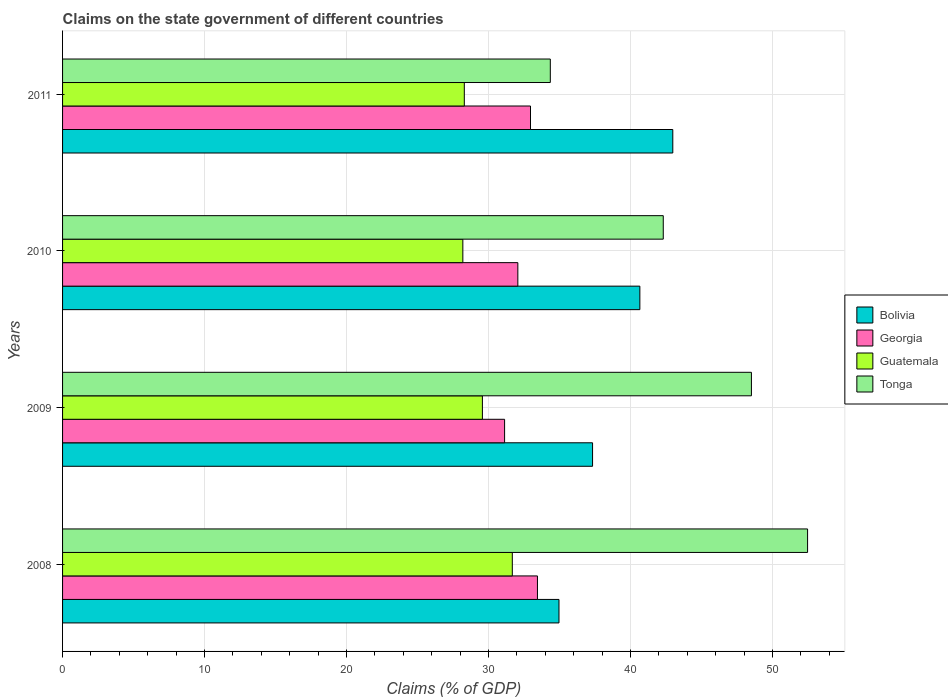How many groups of bars are there?
Your response must be concise. 4. Are the number of bars on each tick of the Y-axis equal?
Provide a succinct answer. Yes. How many bars are there on the 1st tick from the top?
Provide a succinct answer. 4. What is the percentage of GDP claimed on the state government in Tonga in 2011?
Provide a succinct answer. 34.35. Across all years, what is the maximum percentage of GDP claimed on the state government in Bolivia?
Make the answer very short. 42.97. Across all years, what is the minimum percentage of GDP claimed on the state government in Bolivia?
Provide a short and direct response. 34.96. In which year was the percentage of GDP claimed on the state government in Guatemala minimum?
Offer a very short reply. 2010. What is the total percentage of GDP claimed on the state government in Georgia in the graph?
Keep it short and to the point. 129.59. What is the difference between the percentage of GDP claimed on the state government in Georgia in 2009 and that in 2010?
Your answer should be compact. -0.93. What is the difference between the percentage of GDP claimed on the state government in Bolivia in 2009 and the percentage of GDP claimed on the state government in Tonga in 2011?
Offer a very short reply. 2.98. What is the average percentage of GDP claimed on the state government in Bolivia per year?
Offer a terse response. 38.98. In the year 2010, what is the difference between the percentage of GDP claimed on the state government in Bolivia and percentage of GDP claimed on the state government in Georgia?
Your answer should be compact. 8.59. In how many years, is the percentage of GDP claimed on the state government in Guatemala greater than 10 %?
Offer a terse response. 4. What is the ratio of the percentage of GDP claimed on the state government in Guatemala in 2008 to that in 2009?
Your answer should be very brief. 1.07. Is the percentage of GDP claimed on the state government in Georgia in 2009 less than that in 2011?
Give a very brief answer. Yes. What is the difference between the highest and the second highest percentage of GDP claimed on the state government in Tonga?
Your answer should be very brief. 3.96. What is the difference between the highest and the lowest percentage of GDP claimed on the state government in Georgia?
Give a very brief answer. 2.31. In how many years, is the percentage of GDP claimed on the state government in Guatemala greater than the average percentage of GDP claimed on the state government in Guatemala taken over all years?
Provide a short and direct response. 2. Is it the case that in every year, the sum of the percentage of GDP claimed on the state government in Guatemala and percentage of GDP claimed on the state government in Tonga is greater than the sum of percentage of GDP claimed on the state government in Georgia and percentage of GDP claimed on the state government in Bolivia?
Keep it short and to the point. No. What does the 2nd bar from the top in 2011 represents?
Offer a very short reply. Guatemala. What does the 2nd bar from the bottom in 2010 represents?
Provide a succinct answer. Georgia. How many bars are there?
Offer a terse response. 16. Are all the bars in the graph horizontal?
Give a very brief answer. Yes. How many years are there in the graph?
Ensure brevity in your answer.  4. Are the values on the major ticks of X-axis written in scientific E-notation?
Your answer should be very brief. No. Does the graph contain any zero values?
Provide a succinct answer. No. Does the graph contain grids?
Offer a terse response. Yes. Where does the legend appear in the graph?
Give a very brief answer. Center right. How are the legend labels stacked?
Ensure brevity in your answer.  Vertical. What is the title of the graph?
Give a very brief answer. Claims on the state government of different countries. Does "Low income" appear as one of the legend labels in the graph?
Ensure brevity in your answer.  No. What is the label or title of the X-axis?
Give a very brief answer. Claims (% of GDP). What is the Claims (% of GDP) of Bolivia in 2008?
Give a very brief answer. 34.96. What is the Claims (% of GDP) of Georgia in 2008?
Offer a very short reply. 33.44. What is the Claims (% of GDP) in Guatemala in 2008?
Provide a succinct answer. 31.67. What is the Claims (% of GDP) in Tonga in 2008?
Offer a terse response. 52.47. What is the Claims (% of GDP) in Bolivia in 2009?
Ensure brevity in your answer.  37.32. What is the Claims (% of GDP) in Georgia in 2009?
Give a very brief answer. 31.13. What is the Claims (% of GDP) of Guatemala in 2009?
Your answer should be very brief. 29.57. What is the Claims (% of GDP) of Tonga in 2009?
Your response must be concise. 48.51. What is the Claims (% of GDP) in Bolivia in 2010?
Your answer should be very brief. 40.65. What is the Claims (% of GDP) of Georgia in 2010?
Your answer should be very brief. 32.06. What is the Claims (% of GDP) of Guatemala in 2010?
Offer a very short reply. 28.19. What is the Claims (% of GDP) in Tonga in 2010?
Provide a short and direct response. 42.3. What is the Claims (% of GDP) in Bolivia in 2011?
Give a very brief answer. 42.97. What is the Claims (% of GDP) in Georgia in 2011?
Your response must be concise. 32.95. What is the Claims (% of GDP) in Guatemala in 2011?
Keep it short and to the point. 28.29. What is the Claims (% of GDP) in Tonga in 2011?
Your answer should be compact. 34.35. Across all years, what is the maximum Claims (% of GDP) of Bolivia?
Give a very brief answer. 42.97. Across all years, what is the maximum Claims (% of GDP) of Georgia?
Ensure brevity in your answer.  33.44. Across all years, what is the maximum Claims (% of GDP) in Guatemala?
Make the answer very short. 31.67. Across all years, what is the maximum Claims (% of GDP) in Tonga?
Make the answer very short. 52.47. Across all years, what is the minimum Claims (% of GDP) in Bolivia?
Your response must be concise. 34.96. Across all years, what is the minimum Claims (% of GDP) in Georgia?
Keep it short and to the point. 31.13. Across all years, what is the minimum Claims (% of GDP) of Guatemala?
Offer a terse response. 28.19. Across all years, what is the minimum Claims (% of GDP) of Tonga?
Provide a short and direct response. 34.35. What is the total Claims (% of GDP) in Bolivia in the graph?
Your answer should be compact. 155.91. What is the total Claims (% of GDP) of Georgia in the graph?
Give a very brief answer. 129.59. What is the total Claims (% of GDP) in Guatemala in the graph?
Provide a succinct answer. 117.72. What is the total Claims (% of GDP) in Tonga in the graph?
Make the answer very short. 177.63. What is the difference between the Claims (% of GDP) in Bolivia in 2008 and that in 2009?
Your response must be concise. -2.36. What is the difference between the Claims (% of GDP) in Georgia in 2008 and that in 2009?
Make the answer very short. 2.31. What is the difference between the Claims (% of GDP) in Guatemala in 2008 and that in 2009?
Give a very brief answer. 2.11. What is the difference between the Claims (% of GDP) of Tonga in 2008 and that in 2009?
Your answer should be very brief. 3.96. What is the difference between the Claims (% of GDP) of Bolivia in 2008 and that in 2010?
Keep it short and to the point. -5.7. What is the difference between the Claims (% of GDP) of Georgia in 2008 and that in 2010?
Your answer should be very brief. 1.38. What is the difference between the Claims (% of GDP) of Guatemala in 2008 and that in 2010?
Keep it short and to the point. 3.48. What is the difference between the Claims (% of GDP) in Tonga in 2008 and that in 2010?
Your answer should be compact. 10.16. What is the difference between the Claims (% of GDP) of Bolivia in 2008 and that in 2011?
Ensure brevity in your answer.  -8.02. What is the difference between the Claims (% of GDP) in Georgia in 2008 and that in 2011?
Your answer should be compact. 0.49. What is the difference between the Claims (% of GDP) in Guatemala in 2008 and that in 2011?
Your response must be concise. 3.38. What is the difference between the Claims (% of GDP) of Tonga in 2008 and that in 2011?
Your response must be concise. 18.12. What is the difference between the Claims (% of GDP) of Bolivia in 2009 and that in 2010?
Give a very brief answer. -3.33. What is the difference between the Claims (% of GDP) in Georgia in 2009 and that in 2010?
Provide a succinct answer. -0.93. What is the difference between the Claims (% of GDP) in Guatemala in 2009 and that in 2010?
Your response must be concise. 1.38. What is the difference between the Claims (% of GDP) of Tonga in 2009 and that in 2010?
Offer a terse response. 6.21. What is the difference between the Claims (% of GDP) of Bolivia in 2009 and that in 2011?
Provide a succinct answer. -5.65. What is the difference between the Claims (% of GDP) of Georgia in 2009 and that in 2011?
Keep it short and to the point. -1.82. What is the difference between the Claims (% of GDP) in Guatemala in 2009 and that in 2011?
Keep it short and to the point. 1.27. What is the difference between the Claims (% of GDP) of Tonga in 2009 and that in 2011?
Provide a succinct answer. 14.16. What is the difference between the Claims (% of GDP) of Bolivia in 2010 and that in 2011?
Your answer should be compact. -2.32. What is the difference between the Claims (% of GDP) in Georgia in 2010 and that in 2011?
Your response must be concise. -0.89. What is the difference between the Claims (% of GDP) in Guatemala in 2010 and that in 2011?
Your answer should be very brief. -0.1. What is the difference between the Claims (% of GDP) in Tonga in 2010 and that in 2011?
Your answer should be very brief. 7.95. What is the difference between the Claims (% of GDP) of Bolivia in 2008 and the Claims (% of GDP) of Georgia in 2009?
Your answer should be compact. 3.83. What is the difference between the Claims (% of GDP) in Bolivia in 2008 and the Claims (% of GDP) in Guatemala in 2009?
Your answer should be compact. 5.39. What is the difference between the Claims (% of GDP) of Bolivia in 2008 and the Claims (% of GDP) of Tonga in 2009?
Your response must be concise. -13.55. What is the difference between the Claims (% of GDP) in Georgia in 2008 and the Claims (% of GDP) in Guatemala in 2009?
Offer a terse response. 3.88. What is the difference between the Claims (% of GDP) in Georgia in 2008 and the Claims (% of GDP) in Tonga in 2009?
Make the answer very short. -15.07. What is the difference between the Claims (% of GDP) in Guatemala in 2008 and the Claims (% of GDP) in Tonga in 2009?
Provide a succinct answer. -16.84. What is the difference between the Claims (% of GDP) in Bolivia in 2008 and the Claims (% of GDP) in Georgia in 2010?
Offer a terse response. 2.9. What is the difference between the Claims (% of GDP) of Bolivia in 2008 and the Claims (% of GDP) of Guatemala in 2010?
Your answer should be very brief. 6.77. What is the difference between the Claims (% of GDP) of Bolivia in 2008 and the Claims (% of GDP) of Tonga in 2010?
Your answer should be compact. -7.34. What is the difference between the Claims (% of GDP) of Georgia in 2008 and the Claims (% of GDP) of Guatemala in 2010?
Give a very brief answer. 5.25. What is the difference between the Claims (% of GDP) of Georgia in 2008 and the Claims (% of GDP) of Tonga in 2010?
Your response must be concise. -8.86. What is the difference between the Claims (% of GDP) in Guatemala in 2008 and the Claims (% of GDP) in Tonga in 2010?
Give a very brief answer. -10.63. What is the difference between the Claims (% of GDP) of Bolivia in 2008 and the Claims (% of GDP) of Georgia in 2011?
Provide a succinct answer. 2.01. What is the difference between the Claims (% of GDP) in Bolivia in 2008 and the Claims (% of GDP) in Guatemala in 2011?
Offer a terse response. 6.67. What is the difference between the Claims (% of GDP) in Bolivia in 2008 and the Claims (% of GDP) in Tonga in 2011?
Provide a short and direct response. 0.61. What is the difference between the Claims (% of GDP) of Georgia in 2008 and the Claims (% of GDP) of Guatemala in 2011?
Offer a terse response. 5.15. What is the difference between the Claims (% of GDP) in Georgia in 2008 and the Claims (% of GDP) in Tonga in 2011?
Your answer should be very brief. -0.91. What is the difference between the Claims (% of GDP) in Guatemala in 2008 and the Claims (% of GDP) in Tonga in 2011?
Your response must be concise. -2.68. What is the difference between the Claims (% of GDP) of Bolivia in 2009 and the Claims (% of GDP) of Georgia in 2010?
Offer a very short reply. 5.26. What is the difference between the Claims (% of GDP) in Bolivia in 2009 and the Claims (% of GDP) in Guatemala in 2010?
Provide a short and direct response. 9.14. What is the difference between the Claims (% of GDP) of Bolivia in 2009 and the Claims (% of GDP) of Tonga in 2010?
Your answer should be compact. -4.98. What is the difference between the Claims (% of GDP) in Georgia in 2009 and the Claims (% of GDP) in Guatemala in 2010?
Offer a very short reply. 2.94. What is the difference between the Claims (% of GDP) of Georgia in 2009 and the Claims (% of GDP) of Tonga in 2010?
Provide a succinct answer. -11.17. What is the difference between the Claims (% of GDP) of Guatemala in 2009 and the Claims (% of GDP) of Tonga in 2010?
Your response must be concise. -12.74. What is the difference between the Claims (% of GDP) in Bolivia in 2009 and the Claims (% of GDP) in Georgia in 2011?
Offer a terse response. 4.37. What is the difference between the Claims (% of GDP) in Bolivia in 2009 and the Claims (% of GDP) in Guatemala in 2011?
Offer a terse response. 9.03. What is the difference between the Claims (% of GDP) in Bolivia in 2009 and the Claims (% of GDP) in Tonga in 2011?
Your response must be concise. 2.98. What is the difference between the Claims (% of GDP) of Georgia in 2009 and the Claims (% of GDP) of Guatemala in 2011?
Provide a short and direct response. 2.84. What is the difference between the Claims (% of GDP) in Georgia in 2009 and the Claims (% of GDP) in Tonga in 2011?
Offer a terse response. -3.22. What is the difference between the Claims (% of GDP) of Guatemala in 2009 and the Claims (% of GDP) of Tonga in 2011?
Give a very brief answer. -4.78. What is the difference between the Claims (% of GDP) in Bolivia in 2010 and the Claims (% of GDP) in Georgia in 2011?
Give a very brief answer. 7.7. What is the difference between the Claims (% of GDP) of Bolivia in 2010 and the Claims (% of GDP) of Guatemala in 2011?
Provide a short and direct response. 12.36. What is the difference between the Claims (% of GDP) of Bolivia in 2010 and the Claims (% of GDP) of Tonga in 2011?
Make the answer very short. 6.31. What is the difference between the Claims (% of GDP) in Georgia in 2010 and the Claims (% of GDP) in Guatemala in 2011?
Ensure brevity in your answer.  3.77. What is the difference between the Claims (% of GDP) of Georgia in 2010 and the Claims (% of GDP) of Tonga in 2011?
Provide a short and direct response. -2.29. What is the difference between the Claims (% of GDP) in Guatemala in 2010 and the Claims (% of GDP) in Tonga in 2011?
Make the answer very short. -6.16. What is the average Claims (% of GDP) in Bolivia per year?
Keep it short and to the point. 38.98. What is the average Claims (% of GDP) in Georgia per year?
Your response must be concise. 32.4. What is the average Claims (% of GDP) in Guatemala per year?
Ensure brevity in your answer.  29.43. What is the average Claims (% of GDP) in Tonga per year?
Your answer should be compact. 44.41. In the year 2008, what is the difference between the Claims (% of GDP) of Bolivia and Claims (% of GDP) of Georgia?
Give a very brief answer. 1.52. In the year 2008, what is the difference between the Claims (% of GDP) of Bolivia and Claims (% of GDP) of Guatemala?
Offer a very short reply. 3.29. In the year 2008, what is the difference between the Claims (% of GDP) of Bolivia and Claims (% of GDP) of Tonga?
Your response must be concise. -17.51. In the year 2008, what is the difference between the Claims (% of GDP) in Georgia and Claims (% of GDP) in Guatemala?
Provide a short and direct response. 1.77. In the year 2008, what is the difference between the Claims (% of GDP) in Georgia and Claims (% of GDP) in Tonga?
Ensure brevity in your answer.  -19.02. In the year 2008, what is the difference between the Claims (% of GDP) in Guatemala and Claims (% of GDP) in Tonga?
Give a very brief answer. -20.79. In the year 2009, what is the difference between the Claims (% of GDP) of Bolivia and Claims (% of GDP) of Georgia?
Offer a terse response. 6.2. In the year 2009, what is the difference between the Claims (% of GDP) of Bolivia and Claims (% of GDP) of Guatemala?
Keep it short and to the point. 7.76. In the year 2009, what is the difference between the Claims (% of GDP) of Bolivia and Claims (% of GDP) of Tonga?
Provide a succinct answer. -11.19. In the year 2009, what is the difference between the Claims (% of GDP) in Georgia and Claims (% of GDP) in Guatemala?
Offer a terse response. 1.56. In the year 2009, what is the difference between the Claims (% of GDP) in Georgia and Claims (% of GDP) in Tonga?
Keep it short and to the point. -17.38. In the year 2009, what is the difference between the Claims (% of GDP) in Guatemala and Claims (% of GDP) in Tonga?
Offer a terse response. -18.94. In the year 2010, what is the difference between the Claims (% of GDP) in Bolivia and Claims (% of GDP) in Georgia?
Provide a short and direct response. 8.59. In the year 2010, what is the difference between the Claims (% of GDP) of Bolivia and Claims (% of GDP) of Guatemala?
Offer a terse response. 12.47. In the year 2010, what is the difference between the Claims (% of GDP) in Bolivia and Claims (% of GDP) in Tonga?
Keep it short and to the point. -1.65. In the year 2010, what is the difference between the Claims (% of GDP) in Georgia and Claims (% of GDP) in Guatemala?
Ensure brevity in your answer.  3.87. In the year 2010, what is the difference between the Claims (% of GDP) in Georgia and Claims (% of GDP) in Tonga?
Offer a terse response. -10.24. In the year 2010, what is the difference between the Claims (% of GDP) in Guatemala and Claims (% of GDP) in Tonga?
Give a very brief answer. -14.11. In the year 2011, what is the difference between the Claims (% of GDP) in Bolivia and Claims (% of GDP) in Georgia?
Keep it short and to the point. 10.02. In the year 2011, what is the difference between the Claims (% of GDP) in Bolivia and Claims (% of GDP) in Guatemala?
Ensure brevity in your answer.  14.68. In the year 2011, what is the difference between the Claims (% of GDP) in Bolivia and Claims (% of GDP) in Tonga?
Your answer should be compact. 8.63. In the year 2011, what is the difference between the Claims (% of GDP) of Georgia and Claims (% of GDP) of Guatemala?
Offer a terse response. 4.66. In the year 2011, what is the difference between the Claims (% of GDP) of Georgia and Claims (% of GDP) of Tonga?
Keep it short and to the point. -1.4. In the year 2011, what is the difference between the Claims (% of GDP) of Guatemala and Claims (% of GDP) of Tonga?
Offer a terse response. -6.06. What is the ratio of the Claims (% of GDP) in Bolivia in 2008 to that in 2009?
Offer a terse response. 0.94. What is the ratio of the Claims (% of GDP) in Georgia in 2008 to that in 2009?
Provide a short and direct response. 1.07. What is the ratio of the Claims (% of GDP) of Guatemala in 2008 to that in 2009?
Keep it short and to the point. 1.07. What is the ratio of the Claims (% of GDP) of Tonga in 2008 to that in 2009?
Your answer should be compact. 1.08. What is the ratio of the Claims (% of GDP) in Bolivia in 2008 to that in 2010?
Provide a short and direct response. 0.86. What is the ratio of the Claims (% of GDP) in Georgia in 2008 to that in 2010?
Offer a very short reply. 1.04. What is the ratio of the Claims (% of GDP) in Guatemala in 2008 to that in 2010?
Provide a succinct answer. 1.12. What is the ratio of the Claims (% of GDP) in Tonga in 2008 to that in 2010?
Make the answer very short. 1.24. What is the ratio of the Claims (% of GDP) of Bolivia in 2008 to that in 2011?
Provide a succinct answer. 0.81. What is the ratio of the Claims (% of GDP) in Georgia in 2008 to that in 2011?
Offer a terse response. 1.01. What is the ratio of the Claims (% of GDP) of Guatemala in 2008 to that in 2011?
Give a very brief answer. 1.12. What is the ratio of the Claims (% of GDP) of Tonga in 2008 to that in 2011?
Offer a very short reply. 1.53. What is the ratio of the Claims (% of GDP) of Bolivia in 2009 to that in 2010?
Your response must be concise. 0.92. What is the ratio of the Claims (% of GDP) in Georgia in 2009 to that in 2010?
Your answer should be compact. 0.97. What is the ratio of the Claims (% of GDP) in Guatemala in 2009 to that in 2010?
Your answer should be compact. 1.05. What is the ratio of the Claims (% of GDP) in Tonga in 2009 to that in 2010?
Ensure brevity in your answer.  1.15. What is the ratio of the Claims (% of GDP) of Bolivia in 2009 to that in 2011?
Your response must be concise. 0.87. What is the ratio of the Claims (% of GDP) of Georgia in 2009 to that in 2011?
Make the answer very short. 0.94. What is the ratio of the Claims (% of GDP) in Guatemala in 2009 to that in 2011?
Keep it short and to the point. 1.05. What is the ratio of the Claims (% of GDP) of Tonga in 2009 to that in 2011?
Ensure brevity in your answer.  1.41. What is the ratio of the Claims (% of GDP) of Bolivia in 2010 to that in 2011?
Provide a short and direct response. 0.95. What is the ratio of the Claims (% of GDP) of Georgia in 2010 to that in 2011?
Your answer should be compact. 0.97. What is the ratio of the Claims (% of GDP) in Guatemala in 2010 to that in 2011?
Your response must be concise. 1. What is the ratio of the Claims (% of GDP) in Tonga in 2010 to that in 2011?
Your response must be concise. 1.23. What is the difference between the highest and the second highest Claims (% of GDP) in Bolivia?
Your answer should be very brief. 2.32. What is the difference between the highest and the second highest Claims (% of GDP) of Georgia?
Provide a succinct answer. 0.49. What is the difference between the highest and the second highest Claims (% of GDP) of Guatemala?
Keep it short and to the point. 2.11. What is the difference between the highest and the second highest Claims (% of GDP) of Tonga?
Your answer should be compact. 3.96. What is the difference between the highest and the lowest Claims (% of GDP) of Bolivia?
Your answer should be very brief. 8.02. What is the difference between the highest and the lowest Claims (% of GDP) in Georgia?
Provide a succinct answer. 2.31. What is the difference between the highest and the lowest Claims (% of GDP) of Guatemala?
Give a very brief answer. 3.48. What is the difference between the highest and the lowest Claims (% of GDP) of Tonga?
Offer a very short reply. 18.12. 